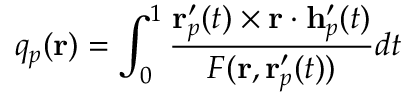<formula> <loc_0><loc_0><loc_500><loc_500>q _ { p } ( r ) = \int _ { 0 } ^ { 1 } \frac { r _ { p } ^ { \prime } ( t ) \times r \cdot h _ { p } ^ { \prime } ( t ) } { F ( r , r _ { p } ^ { \prime } ( t ) ) } d t</formula> 